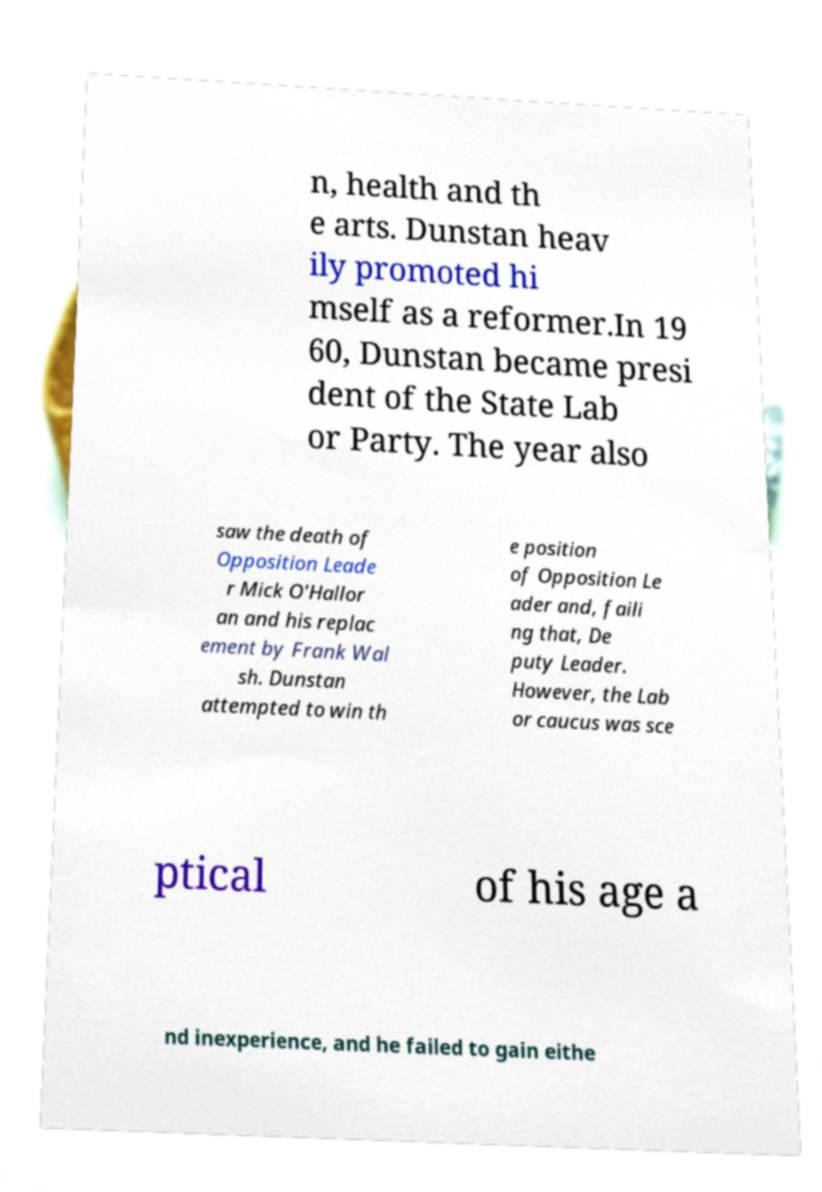Can you accurately transcribe the text from the provided image for me? n, health and th e arts. Dunstan heav ily promoted hi mself as a reformer.In 19 60, Dunstan became presi dent of the State Lab or Party. The year also saw the death of Opposition Leade r Mick O'Hallor an and his replac ement by Frank Wal sh. Dunstan attempted to win th e position of Opposition Le ader and, faili ng that, De puty Leader. However, the Lab or caucus was sce ptical of his age a nd inexperience, and he failed to gain eithe 